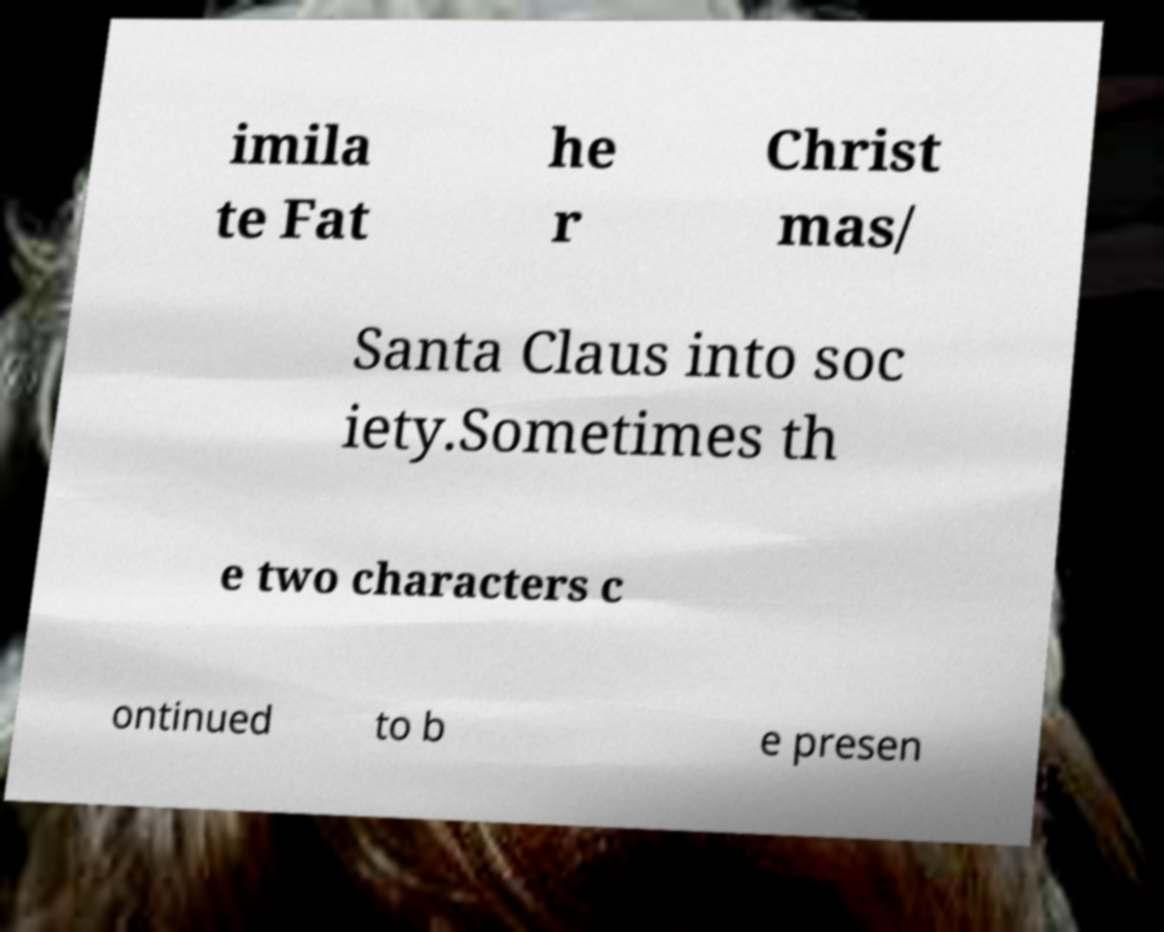Could you assist in decoding the text presented in this image and type it out clearly? imila te Fat he r Christ mas/ Santa Claus into soc iety.Sometimes th e two characters c ontinued to b e presen 